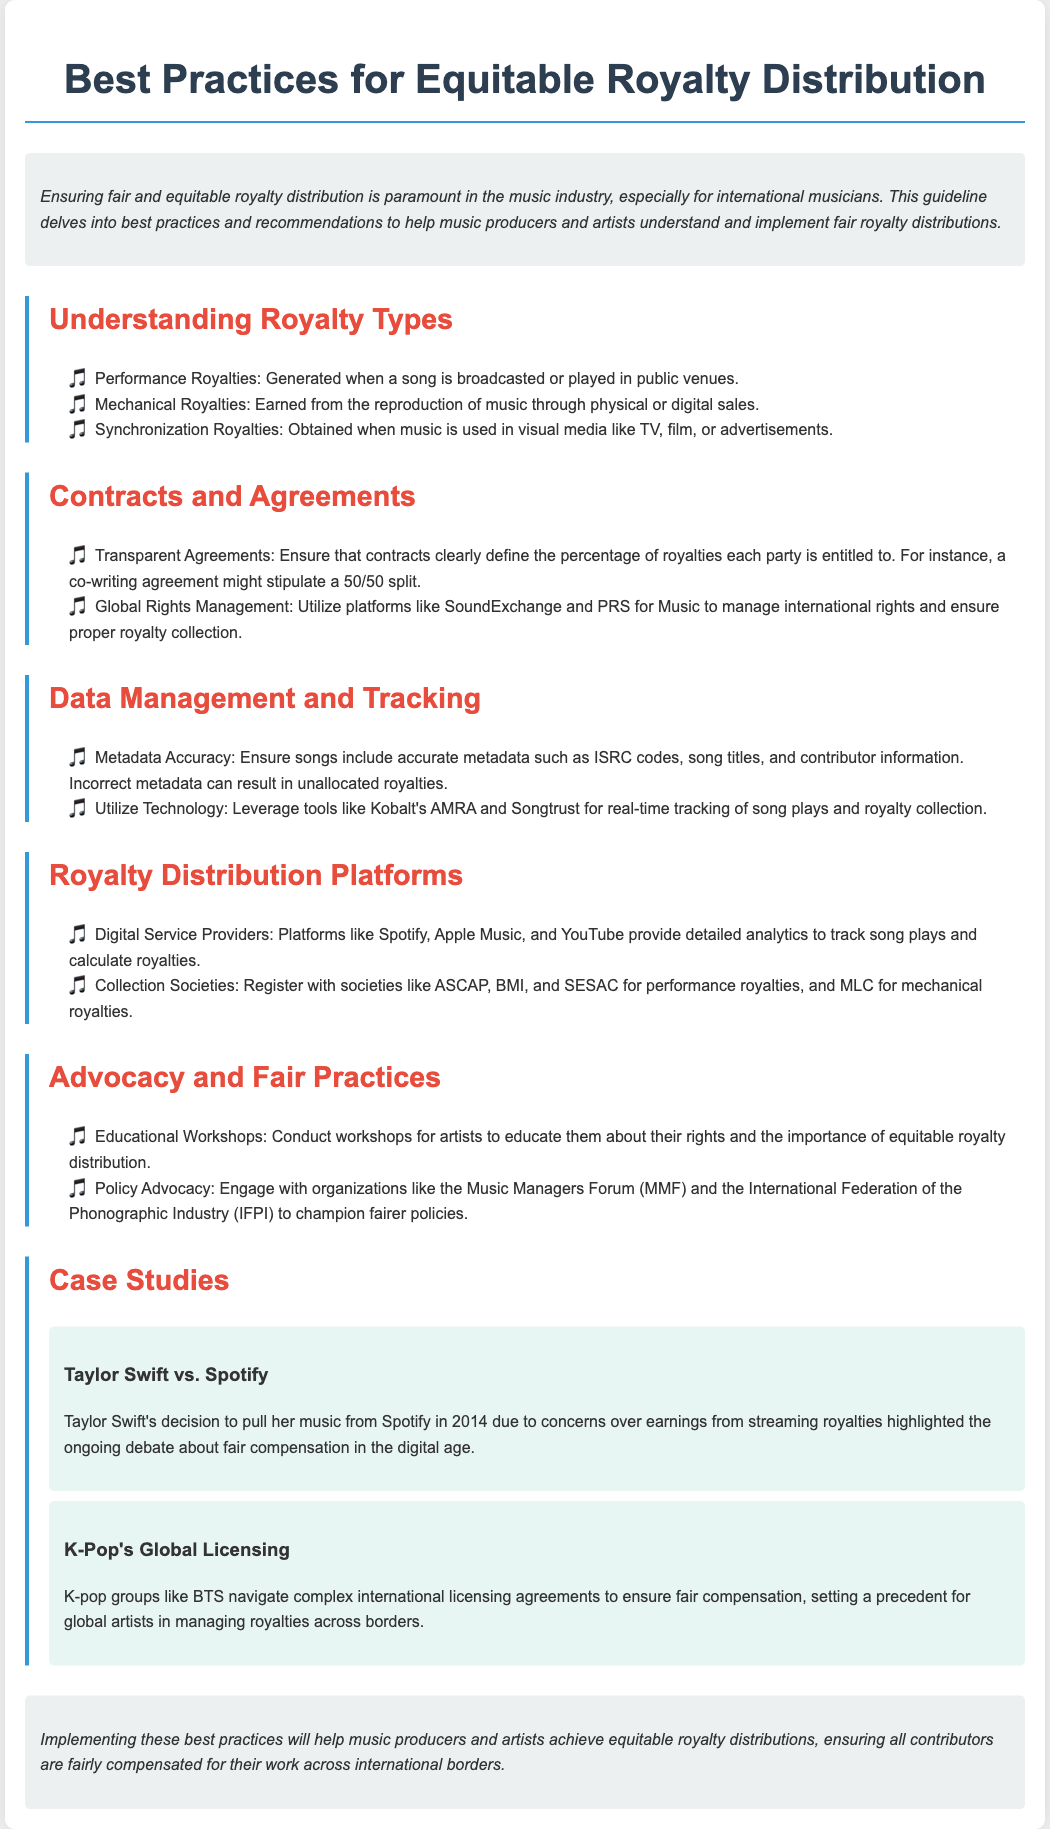what are the three types of royalties mentioned? The document lists three types of royalties: Performance, Mechanical, and Synchronization.
Answer: Performance, Mechanical, Synchronization what should contracts clearly define? The document states that contracts should clearly define the percentage of royalties each party is entitled to.
Answer: percentage of royalties name two platforms for global rights management. The document mentions SoundExchange and PRS for Music as platforms for managing international rights.
Answer: SoundExchange, PRS for Music what is emphasized for song metadata? The document emphasizes the importance of ensuring songs include accurate metadata to avoid unallocated royalties.
Answer: accurate metadata which artist's case highlights the debate about streaming royalties? The document discusses Taylor Swift's case as an example that highlights the debate about fair compensation in streaming royalties.
Answer: Taylor Swift what should producers conduct to educate artists about their rights? The document recommends conducting educational workshops for artists to inform them about equitable royalty distribution.
Answer: workshops which organizations can producers engage with for policy advocacy? The document suggests engaging with the Music Managers Forum and the International Federation of the Phonographic Industry for policy advocacy.
Answer: Music Managers Forum, IFPI what tool can be leveraged for real-time tracking of royalties? The document mentions Kobalt's AMRA as a tool for real-time tracking of song plays and royalty collection.
Answer: Kobalt's AMRA what is the document’s primary focus? The primary focus of the document is on best practices for equitable royalty distribution for music producers and artists.
Answer: equitable royalty distribution 